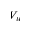Convert formula to latex. <formula><loc_0><loc_0><loc_500><loc_500>V _ { w }</formula> 